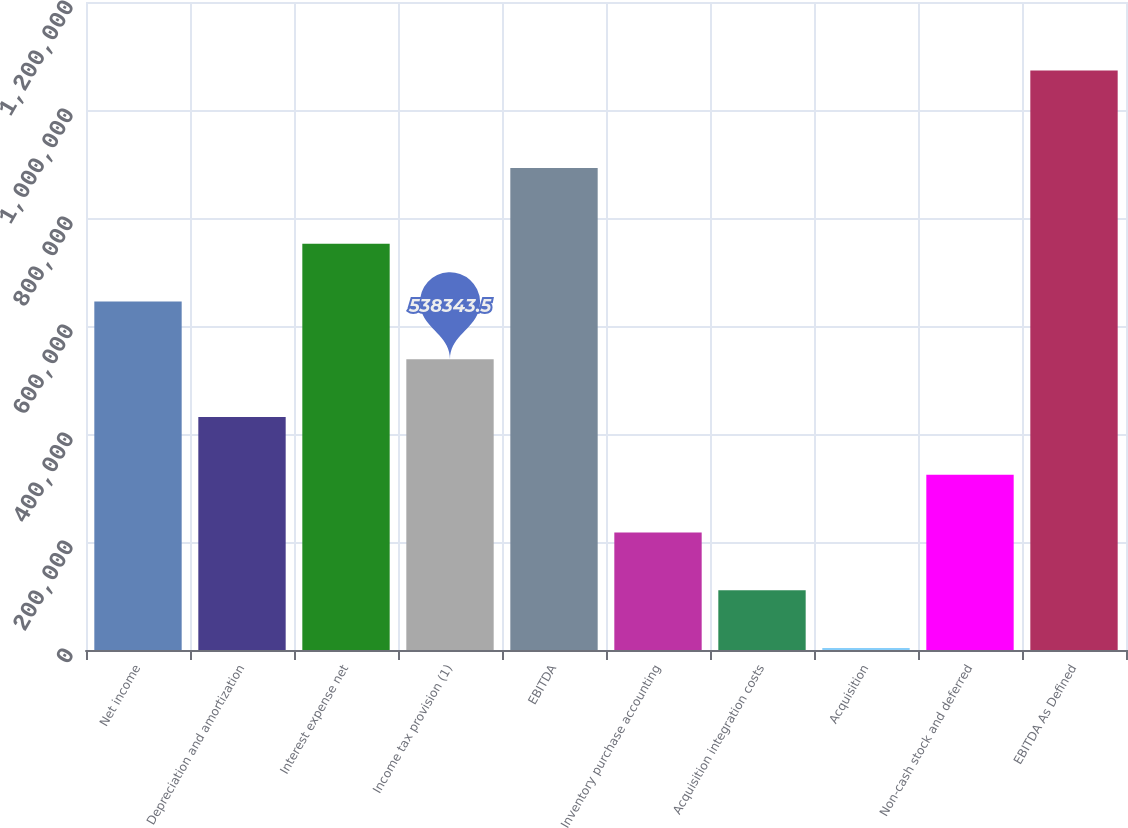Convert chart to OTSL. <chart><loc_0><loc_0><loc_500><loc_500><bar_chart><fcel>Net income<fcel>Depreciation and amortization<fcel>Interest expense net<fcel>Income tax provision (1)<fcel>EBITDA<fcel>Inventory purchase accounting<fcel>Acquisition integration costs<fcel>Acquisition<fcel>Non-cash stock and deferred<fcel>EBITDA As Defined<nl><fcel>645316<fcel>431371<fcel>752289<fcel>538344<fcel>892583<fcel>217425<fcel>110453<fcel>3480<fcel>324398<fcel>1.07321e+06<nl></chart> 